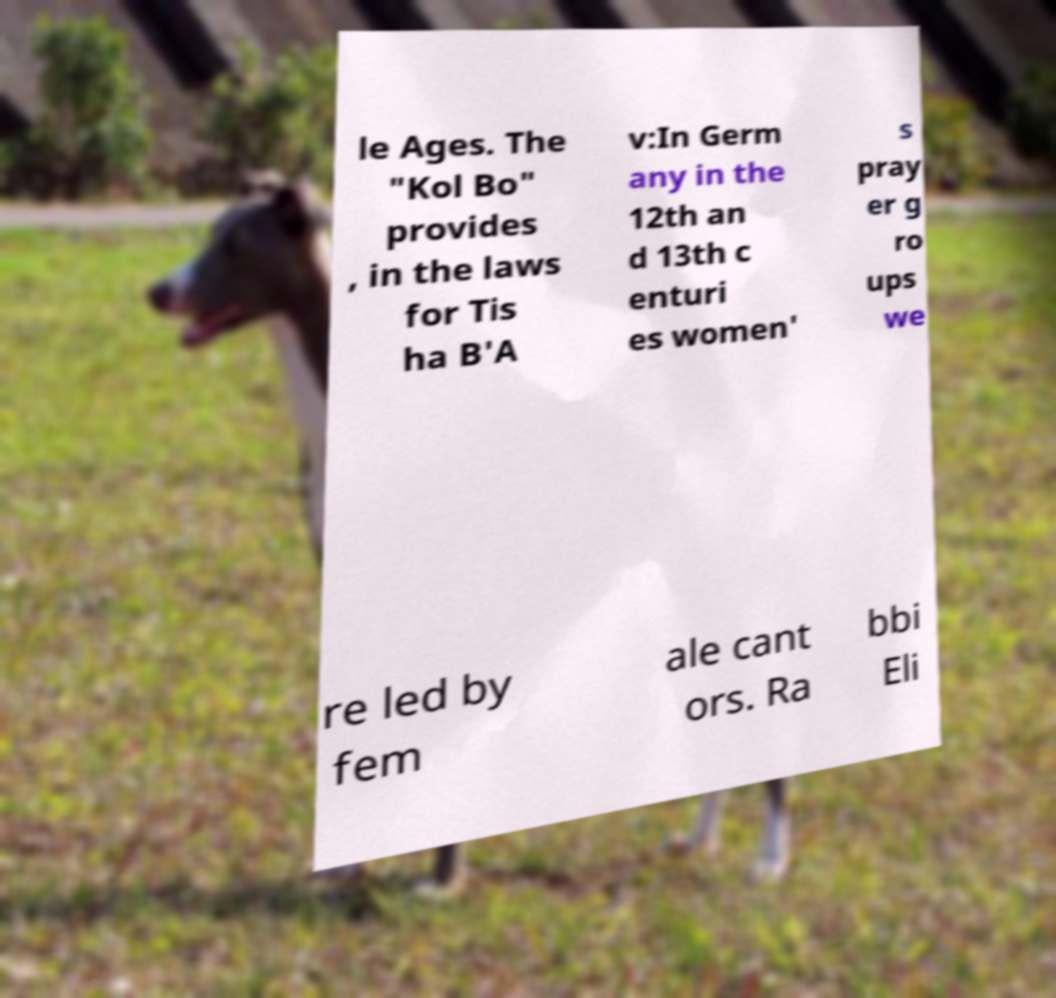Can you read and provide the text displayed in the image?This photo seems to have some interesting text. Can you extract and type it out for me? le Ages. The "Kol Bo" provides , in the laws for Tis ha B'A v:In Germ any in the 12th an d 13th c enturi es women' s pray er g ro ups we re led by fem ale cant ors. Ra bbi Eli 